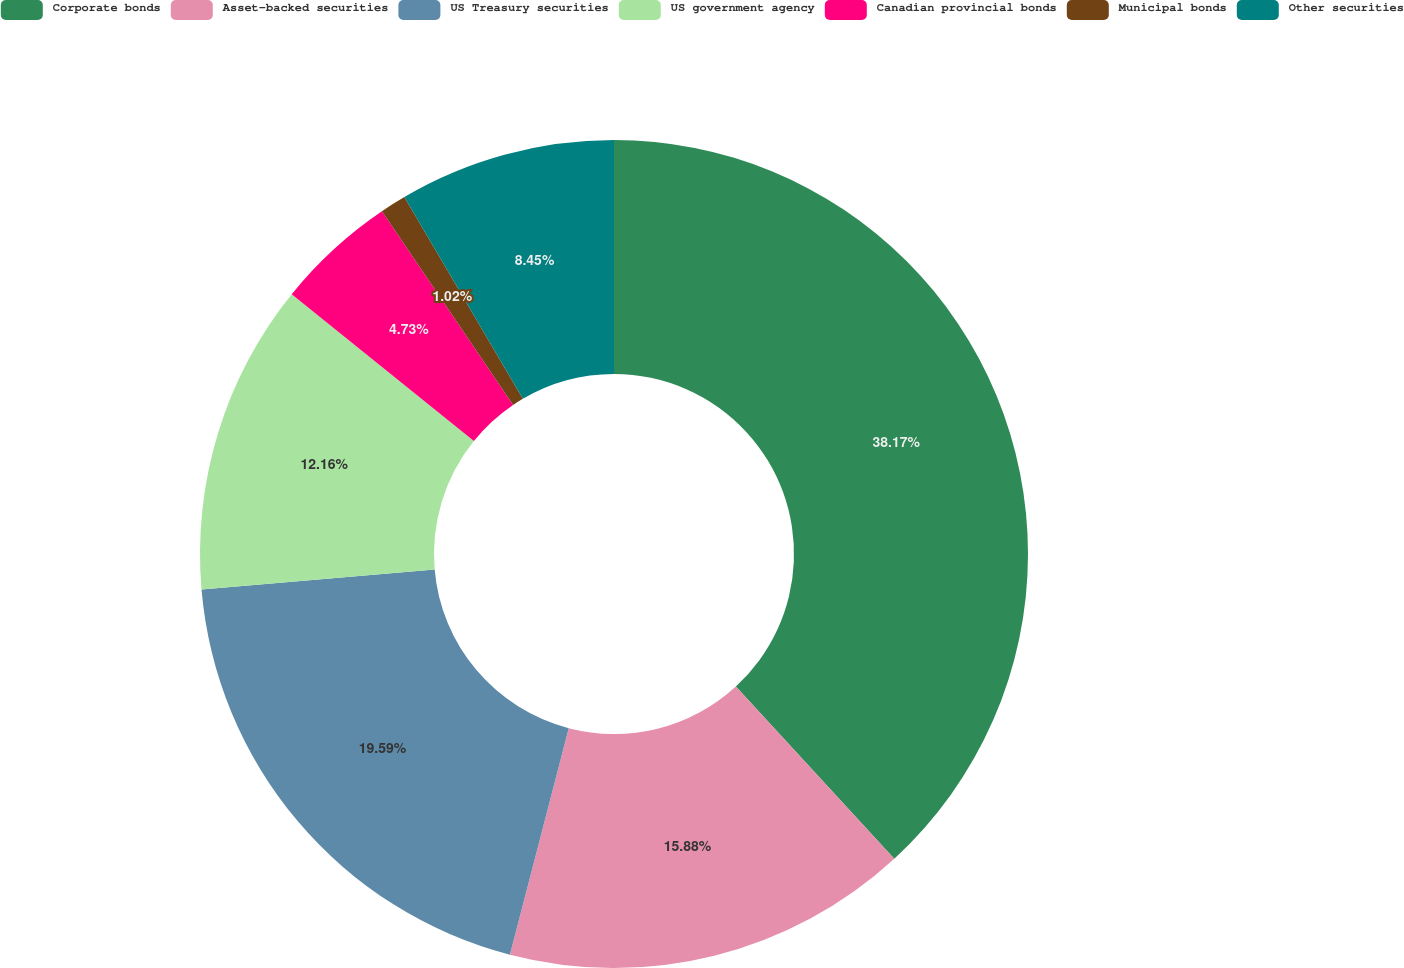<chart> <loc_0><loc_0><loc_500><loc_500><pie_chart><fcel>Corporate bonds<fcel>Asset-backed securities<fcel>US Treasury securities<fcel>US government agency<fcel>Canadian provincial bonds<fcel>Municipal bonds<fcel>Other securities<nl><fcel>38.16%<fcel>15.88%<fcel>19.59%<fcel>12.16%<fcel>4.73%<fcel>1.02%<fcel>8.45%<nl></chart> 